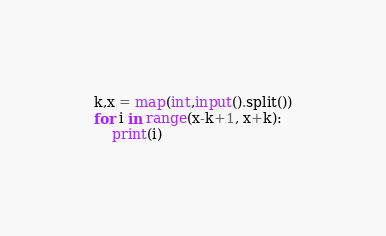<code> <loc_0><loc_0><loc_500><loc_500><_Python_>k,x = map(int,input().split())
for i in range(x-k+1, x+k):
    print(i)</code> 